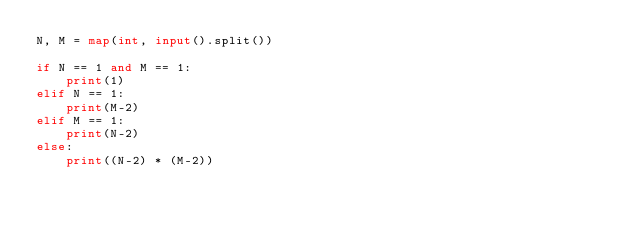<code> <loc_0><loc_0><loc_500><loc_500><_Python_>N, M = map(int, input().split())

if N == 1 and M == 1:
    print(1)
elif N == 1:
    print(M-2)
elif M == 1:
    print(N-2)
else:
    print((N-2) * (M-2))
</code> 